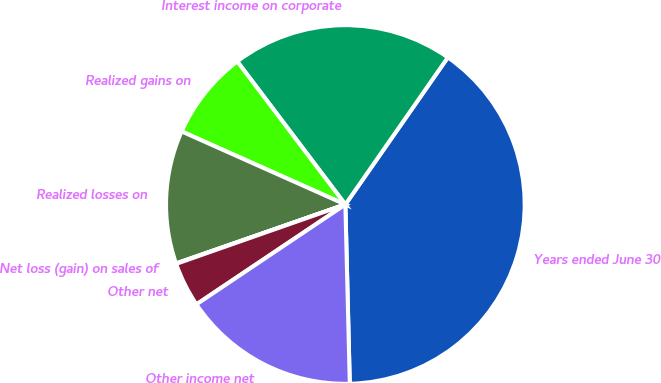Convert chart to OTSL. <chart><loc_0><loc_0><loc_500><loc_500><pie_chart><fcel>Years ended June 30<fcel>Interest income on corporate<fcel>Realized gains on<fcel>Realized losses on<fcel>Net loss (gain) on sales of<fcel>Other net<fcel>Other income net<nl><fcel>39.92%<fcel>19.98%<fcel>8.02%<fcel>12.01%<fcel>0.04%<fcel>4.03%<fcel>15.99%<nl></chart> 